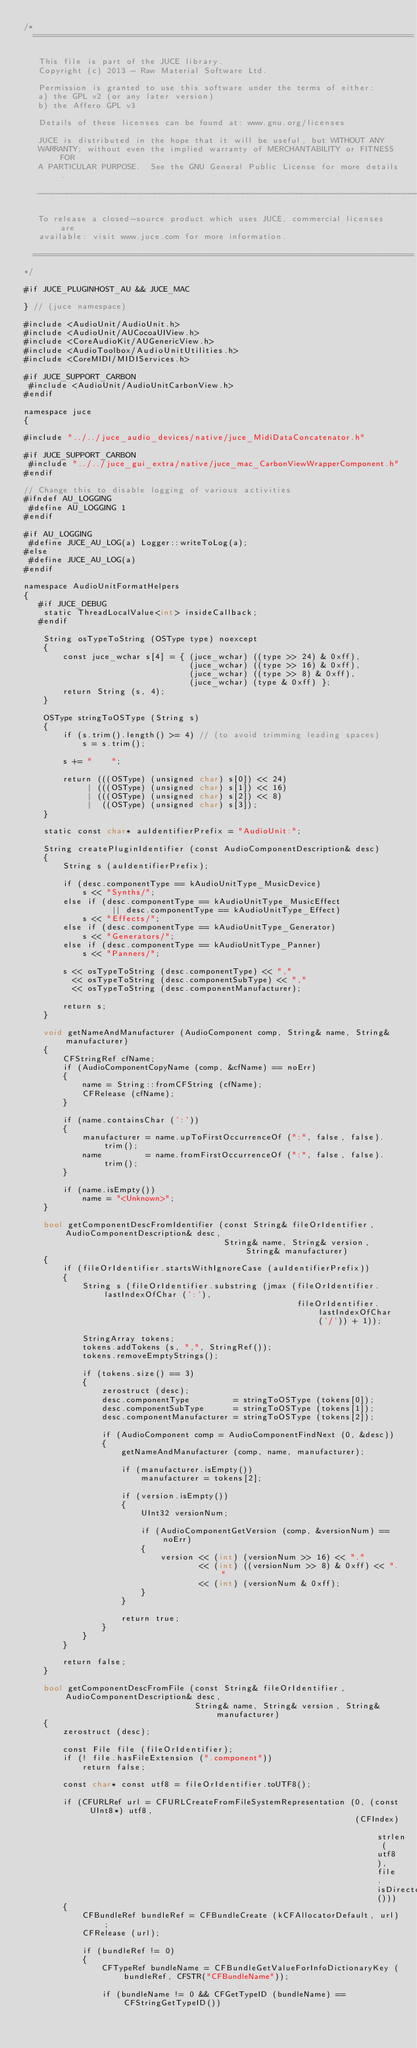<code> <loc_0><loc_0><loc_500><loc_500><_ObjectiveC_>/*
  ==============================================================================

   This file is part of the JUCE library.
   Copyright (c) 2013 - Raw Material Software Ltd.

   Permission is granted to use this software under the terms of either:
   a) the GPL v2 (or any later version)
   b) the Affero GPL v3

   Details of these licenses can be found at: www.gnu.org/licenses

   JUCE is distributed in the hope that it will be useful, but WITHOUT ANY
   WARRANTY; without even the implied warranty of MERCHANTABILITY or FITNESS FOR
   A PARTICULAR PURPOSE.  See the GNU General Public License for more details.

   ------------------------------------------------------------------------------

   To release a closed-source product which uses JUCE, commercial licenses are
   available: visit www.juce.com for more information.

  ==============================================================================
*/

#if JUCE_PLUGINHOST_AU && JUCE_MAC

} // (juce namespace)

#include <AudioUnit/AudioUnit.h>
#include <AudioUnit/AUCocoaUIView.h>
#include <CoreAudioKit/AUGenericView.h>
#include <AudioToolbox/AudioUnitUtilities.h>
#include <CoreMIDI/MIDIServices.h>

#if JUCE_SUPPORT_CARBON
 #include <AudioUnit/AudioUnitCarbonView.h>
#endif

namespace juce
{

#include "../../juce_audio_devices/native/juce_MidiDataConcatenator.h"

#if JUCE_SUPPORT_CARBON
 #include "../../juce_gui_extra/native/juce_mac_CarbonViewWrapperComponent.h"
#endif

// Change this to disable logging of various activities
#ifndef AU_LOGGING
 #define AU_LOGGING 1
#endif

#if AU_LOGGING
 #define JUCE_AU_LOG(a) Logger::writeToLog(a);
#else
 #define JUCE_AU_LOG(a)
#endif

namespace AudioUnitFormatHelpers
{
   #if JUCE_DEBUG
    static ThreadLocalValue<int> insideCallback;
   #endif

    String osTypeToString (OSType type) noexcept
    {
        const juce_wchar s[4] = { (juce_wchar) ((type >> 24) & 0xff),
                                  (juce_wchar) ((type >> 16) & 0xff),
                                  (juce_wchar) ((type >> 8) & 0xff),
                                  (juce_wchar) (type & 0xff) };
        return String (s, 4);
    }

    OSType stringToOSType (String s)
    {
        if (s.trim().length() >= 4) // (to avoid trimming leading spaces)
            s = s.trim();

        s += "    ";

        return (((OSType) (unsigned char) s[0]) << 24)
             | (((OSType) (unsigned char) s[1]) << 16)
             | (((OSType) (unsigned char) s[2]) << 8)
             |  ((OSType) (unsigned char) s[3]);
    }

    static const char* auIdentifierPrefix = "AudioUnit:";

    String createPluginIdentifier (const AudioComponentDescription& desc)
    {
        String s (auIdentifierPrefix);

        if (desc.componentType == kAudioUnitType_MusicDevice)
            s << "Synths/";
        else if (desc.componentType == kAudioUnitType_MusicEffect
                  || desc.componentType == kAudioUnitType_Effect)
            s << "Effects/";
        else if (desc.componentType == kAudioUnitType_Generator)
            s << "Generators/";
        else if (desc.componentType == kAudioUnitType_Panner)
            s << "Panners/";

        s << osTypeToString (desc.componentType) << ","
          << osTypeToString (desc.componentSubType) << ","
          << osTypeToString (desc.componentManufacturer);

        return s;
    }

    void getNameAndManufacturer (AudioComponent comp, String& name, String& manufacturer)
    {
        CFStringRef cfName;
        if (AudioComponentCopyName (comp, &cfName) == noErr)
        {
            name = String::fromCFString (cfName);
            CFRelease (cfName);
        }

        if (name.containsChar (':'))
        {
            manufacturer = name.upToFirstOccurrenceOf (":", false, false).trim();
            name         = name.fromFirstOccurrenceOf (":", false, false).trim();
        }

        if (name.isEmpty())
            name = "<Unknown>";
    }

    bool getComponentDescFromIdentifier (const String& fileOrIdentifier, AudioComponentDescription& desc,
                                         String& name, String& version, String& manufacturer)
    {
        if (fileOrIdentifier.startsWithIgnoreCase (auIdentifierPrefix))
        {
            String s (fileOrIdentifier.substring (jmax (fileOrIdentifier.lastIndexOfChar (':'),
                                                        fileOrIdentifier.lastIndexOfChar ('/')) + 1));

            StringArray tokens;
            tokens.addTokens (s, ",", StringRef());
            tokens.removeEmptyStrings();

            if (tokens.size() == 3)
            {
                zerostruct (desc);
                desc.componentType         = stringToOSType (tokens[0]);
                desc.componentSubType      = stringToOSType (tokens[1]);
                desc.componentManufacturer = stringToOSType (tokens[2]);

                if (AudioComponent comp = AudioComponentFindNext (0, &desc))
                {
                    getNameAndManufacturer (comp, name, manufacturer);

                    if (manufacturer.isEmpty())
                        manufacturer = tokens[2];

                    if (version.isEmpty())
                    {
                        UInt32 versionNum;

                        if (AudioComponentGetVersion (comp, &versionNum) == noErr)
                        {
                            version << (int) (versionNum >> 16) << "."
                                    << (int) ((versionNum >> 8) & 0xff) << "."
                                    << (int) (versionNum & 0xff);
                        }
                    }

                    return true;
                }
            }
        }

        return false;
    }

    bool getComponentDescFromFile (const String& fileOrIdentifier, AudioComponentDescription& desc,
                                   String& name, String& version, String& manufacturer)
    {
        zerostruct (desc);

        const File file (fileOrIdentifier);
        if (! file.hasFileExtension (".component"))
            return false;

        const char* const utf8 = fileOrIdentifier.toUTF8();

        if (CFURLRef url = CFURLCreateFromFileSystemRepresentation (0, (const UInt8*) utf8,
                                                                    (CFIndex) strlen (utf8), file.isDirectory()))
        {
            CFBundleRef bundleRef = CFBundleCreate (kCFAllocatorDefault, url);
            CFRelease (url);

            if (bundleRef != 0)
            {
                CFTypeRef bundleName = CFBundleGetValueForInfoDictionaryKey (bundleRef, CFSTR("CFBundleName"));

                if (bundleName != 0 && CFGetTypeID (bundleName) == CFStringGetTypeID())</code> 